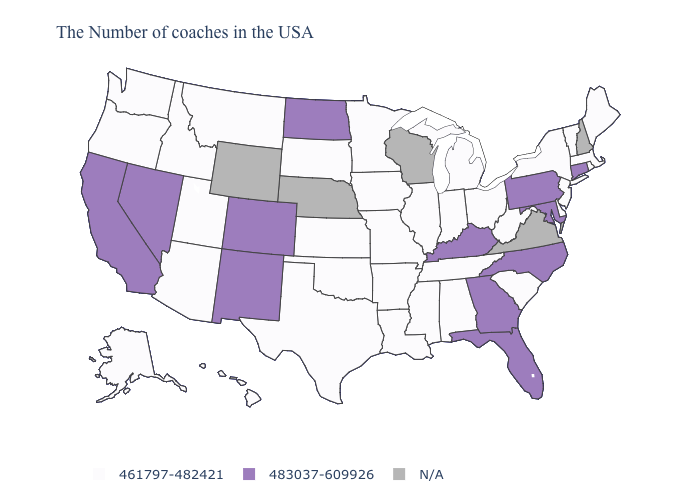What is the highest value in the USA?
Be succinct. 483037-609926. What is the highest value in the South ?
Concise answer only. 483037-609926. Name the states that have a value in the range N/A?
Keep it brief. New Hampshire, Virginia, Wisconsin, Nebraska, Wyoming. Does the map have missing data?
Give a very brief answer. Yes. Does the first symbol in the legend represent the smallest category?
Answer briefly. Yes. Name the states that have a value in the range 461797-482421?
Give a very brief answer. Maine, Massachusetts, Rhode Island, Vermont, New York, New Jersey, Delaware, South Carolina, West Virginia, Ohio, Michigan, Indiana, Alabama, Tennessee, Illinois, Mississippi, Louisiana, Missouri, Arkansas, Minnesota, Iowa, Kansas, Oklahoma, Texas, South Dakota, Utah, Montana, Arizona, Idaho, Washington, Oregon, Alaska, Hawaii. What is the value of Arizona?
Quick response, please. 461797-482421. Among the states that border Oregon , does Washington have the lowest value?
Keep it brief. Yes. Does Oregon have the highest value in the USA?
Concise answer only. No. Among the states that border California , which have the lowest value?
Be succinct. Arizona, Oregon. What is the highest value in the USA?
Concise answer only. 483037-609926. Does the first symbol in the legend represent the smallest category?
Write a very short answer. Yes. Does Massachusetts have the lowest value in the USA?
Concise answer only. Yes. 